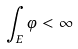Convert formula to latex. <formula><loc_0><loc_0><loc_500><loc_500>\int _ { E } \varphi < \infty</formula> 